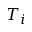<formula> <loc_0><loc_0><loc_500><loc_500>T _ { i }</formula> 